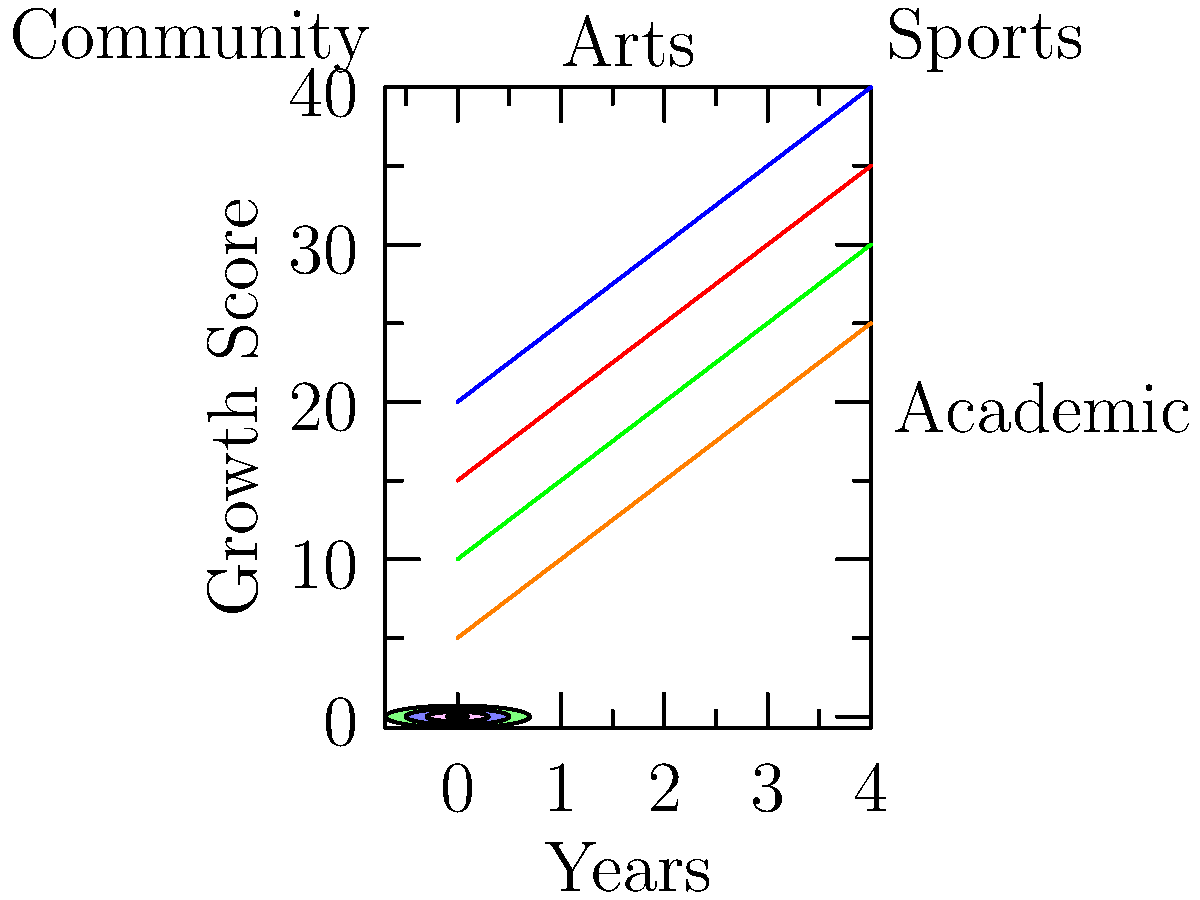Based on the stacked area chart showing the relationship between extracurricular activities and personal growth over time, which activity appears to have the most significant impact on overall growth? How might this information influence a parent's decision to encourage their child's participation in specific activities? To answer this question, we need to analyze the stacked area chart:

1. Identify the activities: The chart shows four activities - Academic, Sports, Arts, and Community service.

2. Observe growth trends: All activities show an increasing trend over time.

3. Compare areas: The largest area corresponds to the activity with the most significant impact on overall growth.

4. Analyze the areas:
   - Academic (blue) has the largest area and steepest growth curve.
   - Sports (red) has the second-largest area.
   - Arts (green) and Community service (orange) have smaller but still significant areas.

5. Interpret the results: Academic activities appear to have the most significant impact on overall growth, followed by sports, arts, and community service.

6. Consider parental perspective:
   - A parent might prioritize academic activities given their apparent strong influence on growth.
   - However, a well-rounded approach including all activities could provide balanced development.
   - The parent might encourage participation in academic clubs or competitions while also promoting involvement in sports, arts, and community service for holistic growth.

7. Relate to the persona: As a single mother who values the youth academy's influence, she might appreciate how these diverse activities contribute to her child's success and growth, aligning with the academy's values.
Answer: Academic activities have the most significant impact; parents may prioritize these while encouraging balanced participation in all activities for holistic development. 